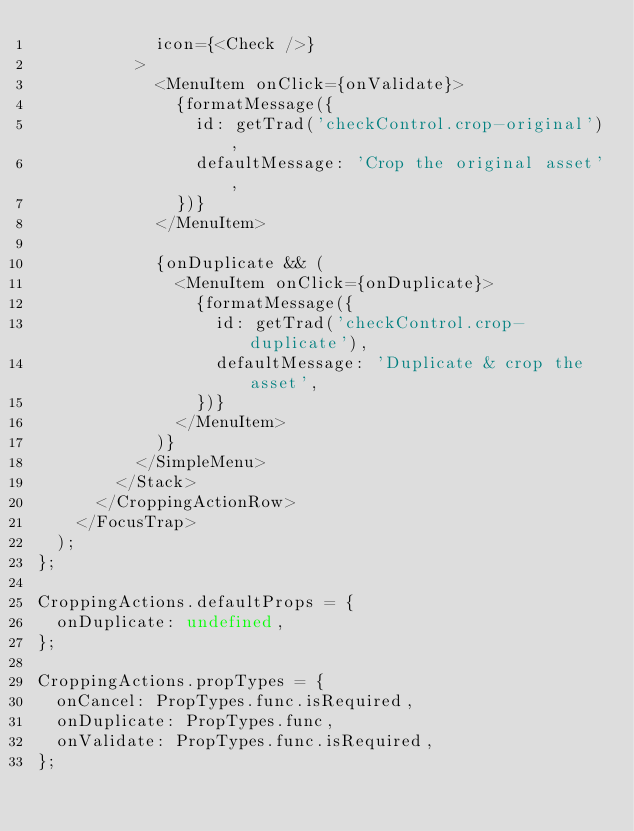Convert code to text. <code><loc_0><loc_0><loc_500><loc_500><_JavaScript_>            icon={<Check />}
          >
            <MenuItem onClick={onValidate}>
              {formatMessage({
                id: getTrad('checkControl.crop-original'),
                defaultMessage: 'Crop the original asset',
              })}
            </MenuItem>

            {onDuplicate && (
              <MenuItem onClick={onDuplicate}>
                {formatMessage({
                  id: getTrad('checkControl.crop-duplicate'),
                  defaultMessage: 'Duplicate & crop the asset',
                })}
              </MenuItem>
            )}
          </SimpleMenu>
        </Stack>
      </CroppingActionRow>
    </FocusTrap>
  );
};

CroppingActions.defaultProps = {
  onDuplicate: undefined,
};

CroppingActions.propTypes = {
  onCancel: PropTypes.func.isRequired,
  onDuplicate: PropTypes.func,
  onValidate: PropTypes.func.isRequired,
};
</code> 